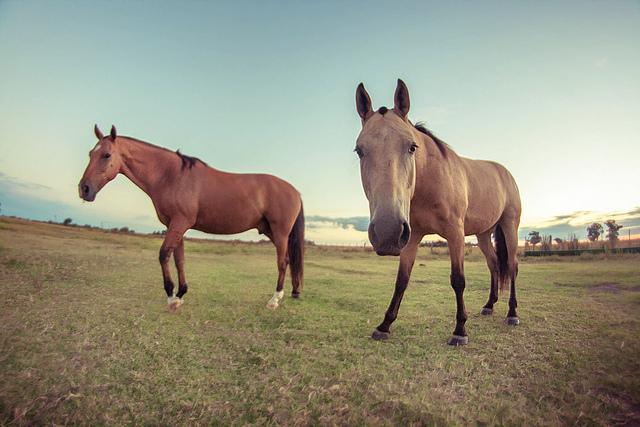How many horses are there?
Give a very brief answer. 2. How many men are holding a racket?
Give a very brief answer. 0. 